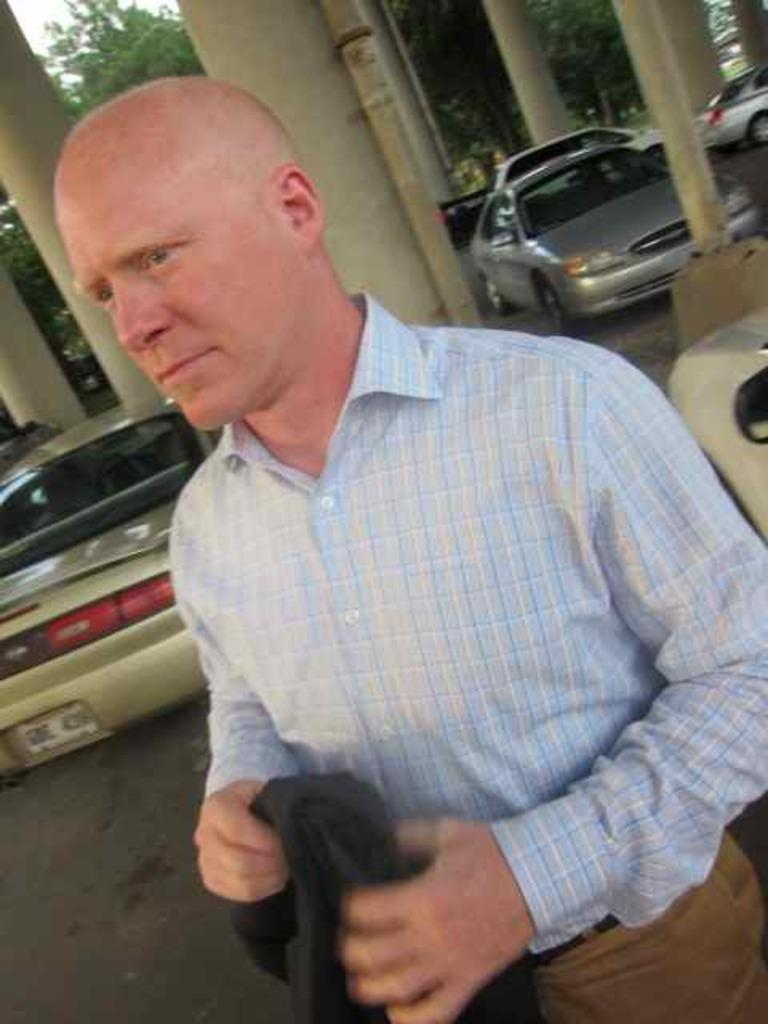What is present in the image? There is a man in the image. What is the man holding in his hand? The man is holding something in his hand. What can be seen in the background of the image? There are cars, pillars, and trees in the background of the image. How many ants can be seen crawling on the iron in the image? There is no iron or ants present in the image. 